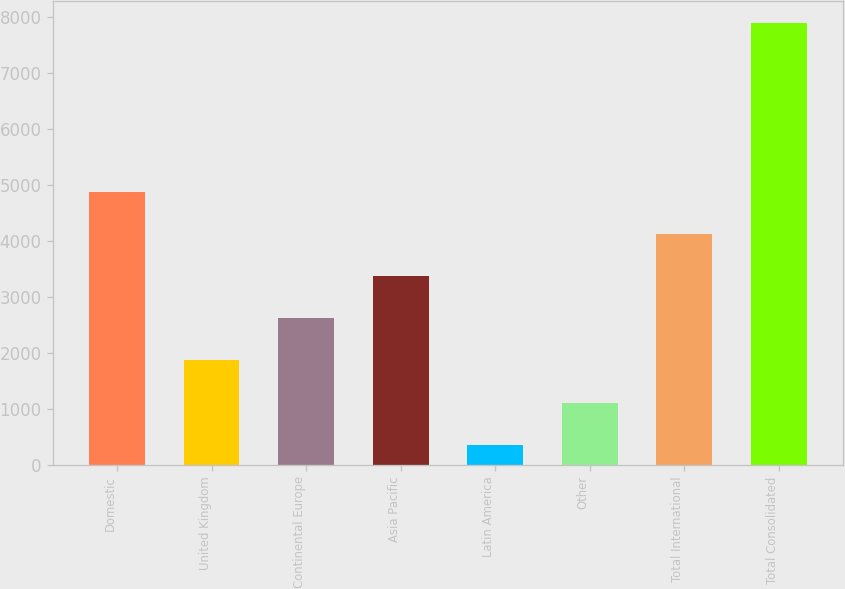Convert chart. <chart><loc_0><loc_0><loc_500><loc_500><bar_chart><fcel>Domestic<fcel>United Kingdom<fcel>Continental Europe<fcel>Asia Pacific<fcel>Latin America<fcel>Other<fcel>Total International<fcel>Total Consolidated<nl><fcel>4871.8<fcel>1861.2<fcel>2613.85<fcel>3366.5<fcel>355.9<fcel>1108.55<fcel>4119.15<fcel>7882.4<nl></chart> 